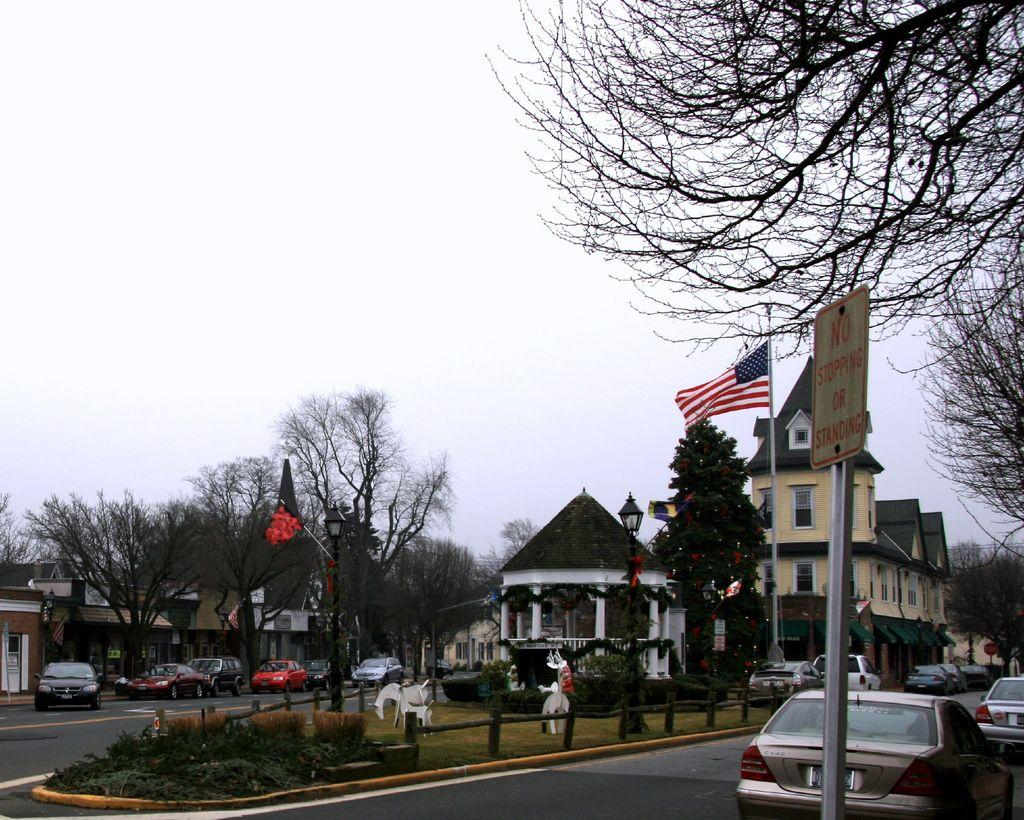What can be seen on the road in the image? There are vehicles on the road in the image. What type of natural elements are visible in the background of the image? There are trees in the background of the image. What type of structures can be seen in the background of the image? There are buildings in white and cream color in the background of the image. What is visible in the sky in the image? The sky is visible in the background of the image, and it is white in color. Can you find the receipt for the purchase of the wheel in the image? There is no receipt or wheel present in the image. What type of plate is being used by the vehicles in the image? The image does not show any plates being used by the vehicles; it only shows the vehicles on the road. 